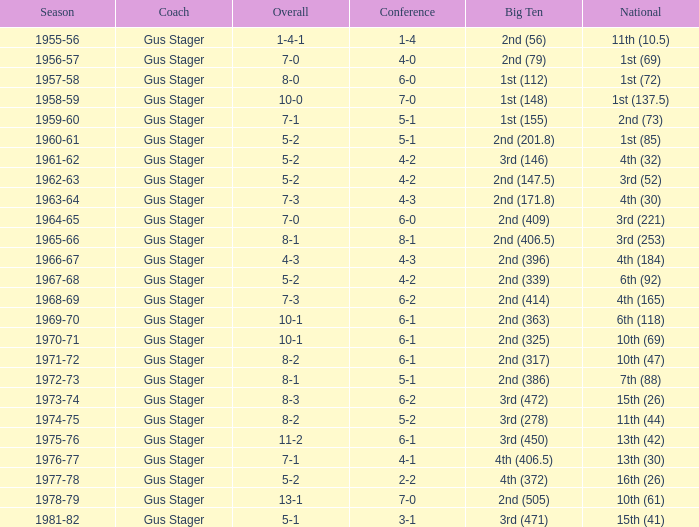What is the Coach with a Big Ten that is 3rd (278)? Gus Stager. 